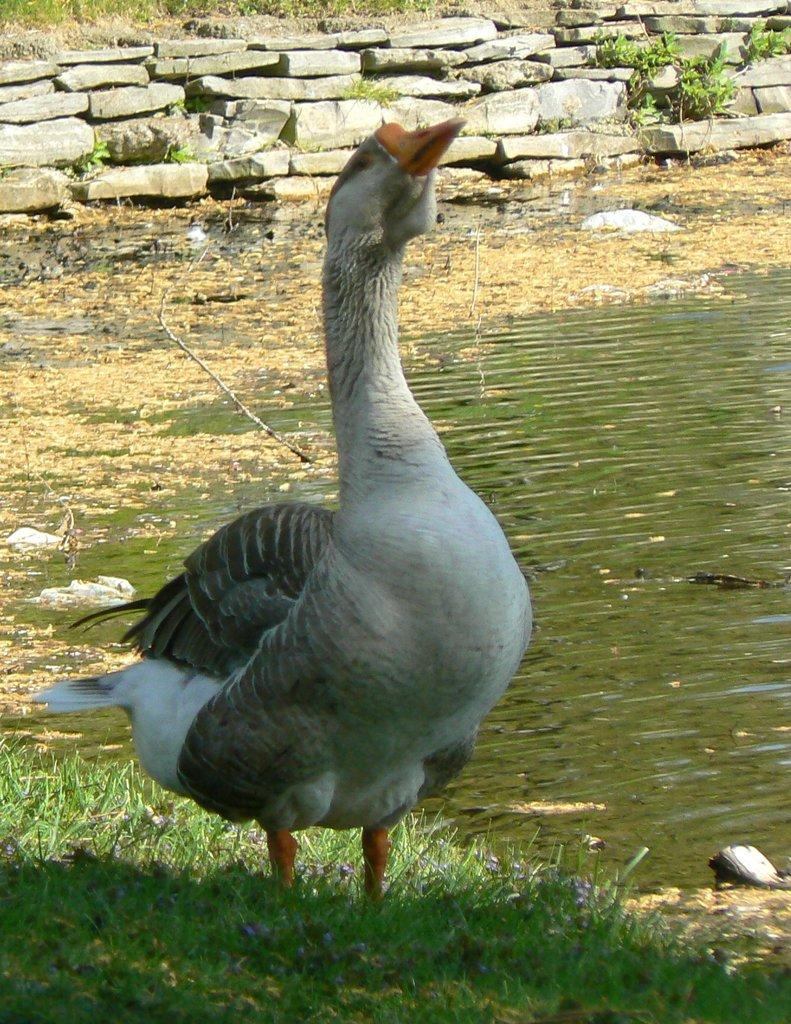What type of animal is in the image? There is a bird in the image. Can you describe the bird's coloring? The bird is white and black in color. What type of vegetation can be seen in the image? There is green grass visible in the image. What else is present in the image besides the bird and grass? There is water and stones in the image. What type of knife is the bird using to cut the oatmeal in the image? There is no knife or oatmeal present in the image; it features a bird in a natural setting with grass, water, and stones. 